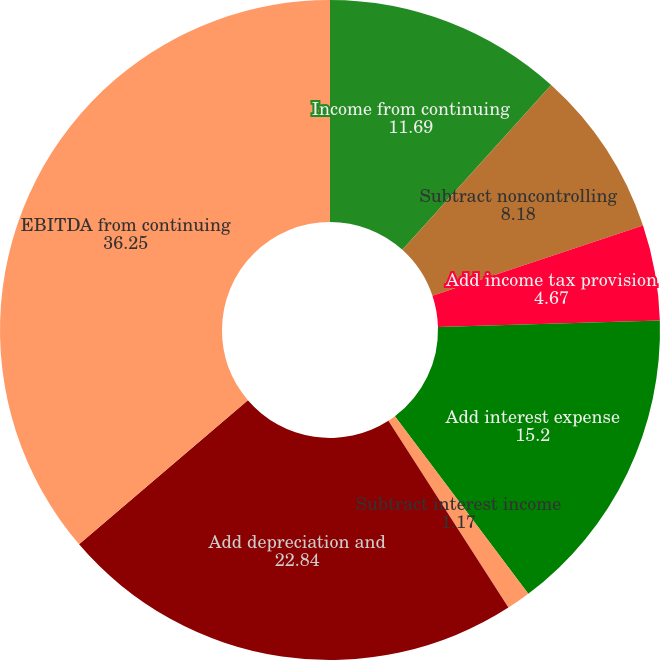Convert chart to OTSL. <chart><loc_0><loc_0><loc_500><loc_500><pie_chart><fcel>Income from continuing<fcel>Subtract noncontrolling<fcel>Add income tax provision<fcel>Add interest expense<fcel>Subtract interest income<fcel>Add depreciation and<fcel>EBITDA from continuing<nl><fcel>11.69%<fcel>8.18%<fcel>4.67%<fcel>15.2%<fcel>1.17%<fcel>22.84%<fcel>36.25%<nl></chart> 